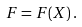Convert formula to latex. <formula><loc_0><loc_0><loc_500><loc_500>F = F ( X ) \, .</formula> 